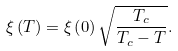<formula> <loc_0><loc_0><loc_500><loc_500>\xi \left ( T \right ) = \xi \left ( 0 \right ) \sqrt { \frac { T _ { c } } { T _ { c } - T } } .</formula> 